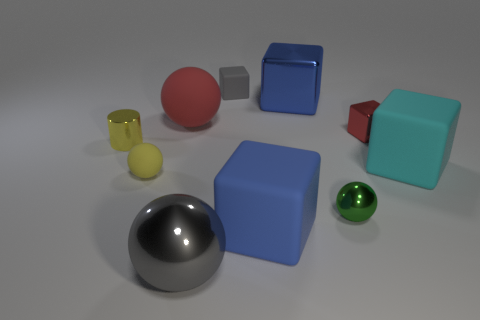Are there fewer small yellow shiny objects right of the tiny yellow metallic object than rubber objects on the right side of the red ball?
Keep it short and to the point. Yes. What number of small red metallic cubes are in front of the rubber sphere that is behind the yellow ball?
Your response must be concise. 1. Are any tiny shiny cylinders visible?
Offer a very short reply. Yes. Are there any big blue objects that have the same material as the red sphere?
Your answer should be very brief. Yes. Is the number of gray metal balls right of the tiny metallic cylinder greater than the number of red metal things in front of the green shiny object?
Offer a terse response. Yes. Do the yellow ball and the green ball have the same size?
Your answer should be very brief. Yes. There is a large ball that is in front of the big blue cube that is in front of the yellow shiny cylinder; what color is it?
Provide a short and direct response. Gray. The large rubber sphere has what color?
Your response must be concise. Red. Are there any objects that have the same color as the small rubber block?
Make the answer very short. Yes. Is the color of the tiny matte thing that is behind the tiny yellow rubber ball the same as the big metallic sphere?
Your response must be concise. Yes. 